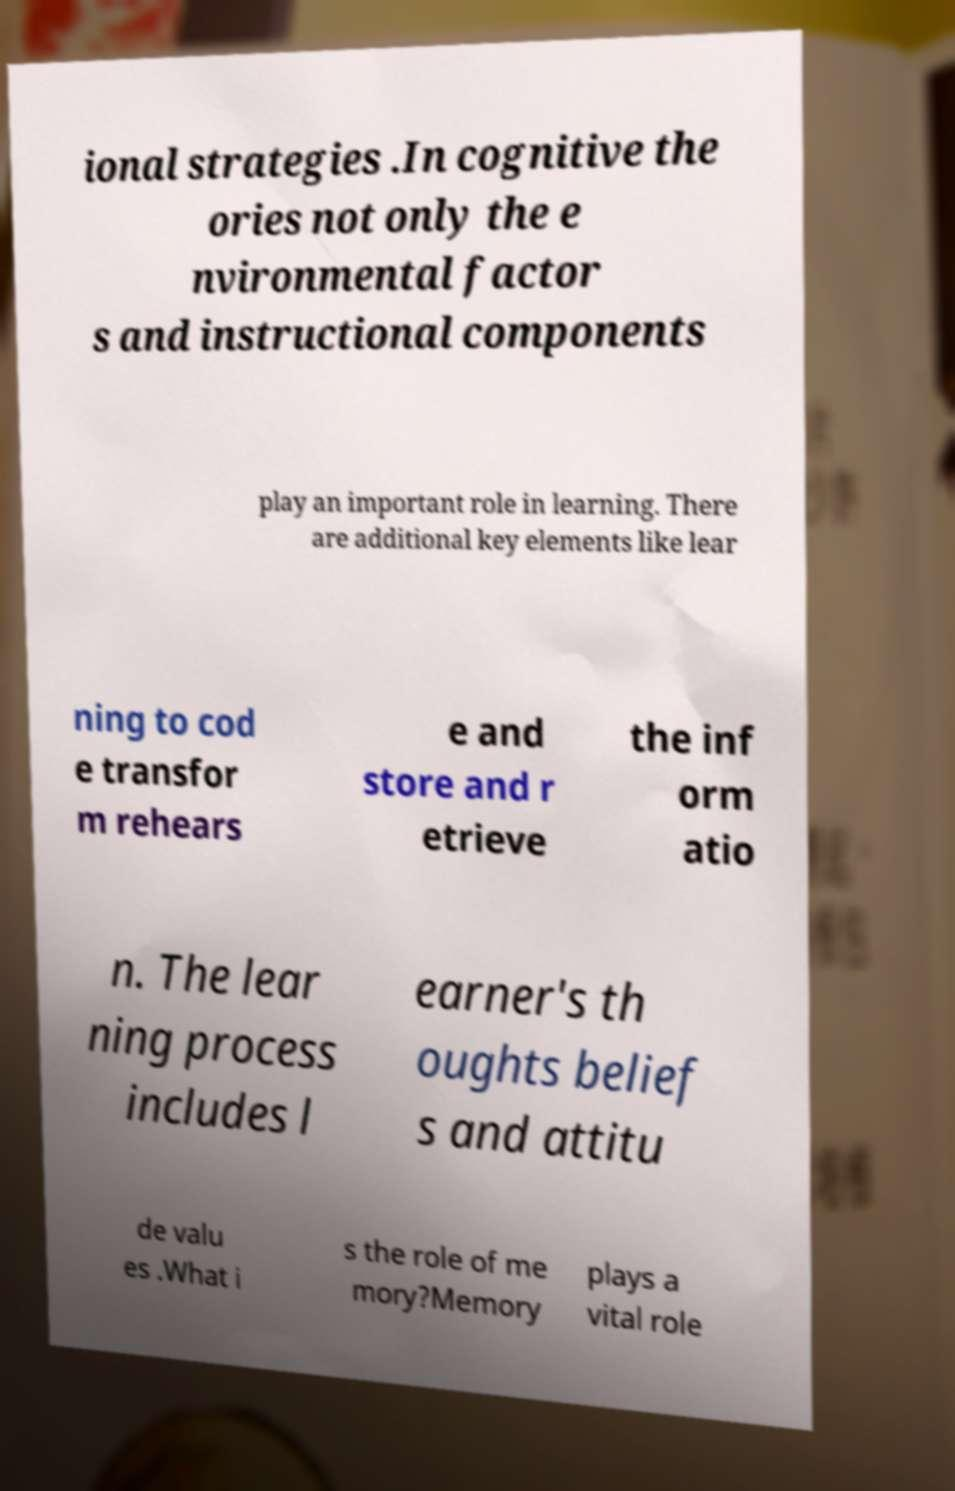Please read and relay the text visible in this image. What does it say? ional strategies .In cognitive the ories not only the e nvironmental factor s and instructional components play an important role in learning. There are additional key elements like lear ning to cod e transfor m rehears e and store and r etrieve the inf orm atio n. The lear ning process includes l earner's th oughts belief s and attitu de valu es .What i s the role of me mory?Memory plays a vital role 